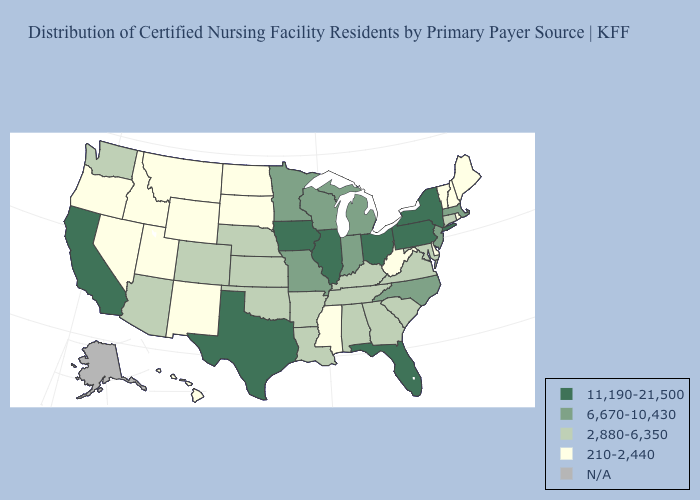Name the states that have a value in the range N/A?
Quick response, please. Alaska. Does the first symbol in the legend represent the smallest category?
Short answer required. No. What is the value of Alaska?
Be succinct. N/A. Among the states that border Oklahoma , does Arkansas have the highest value?
Be succinct. No. Name the states that have a value in the range 6,670-10,430?
Quick response, please. Indiana, Massachusetts, Michigan, Minnesota, Missouri, New Jersey, North Carolina, Wisconsin. Name the states that have a value in the range 6,670-10,430?
Keep it brief. Indiana, Massachusetts, Michigan, Minnesota, Missouri, New Jersey, North Carolina, Wisconsin. Does Florida have the lowest value in the USA?
Short answer required. No. Name the states that have a value in the range 2,880-6,350?
Quick response, please. Alabama, Arizona, Arkansas, Colorado, Connecticut, Georgia, Kansas, Kentucky, Louisiana, Maryland, Nebraska, Oklahoma, South Carolina, Tennessee, Virginia, Washington. What is the value of California?
Write a very short answer. 11,190-21,500. What is the lowest value in states that border Minnesota?
Write a very short answer. 210-2,440. What is the lowest value in the West?
Concise answer only. 210-2,440. Does West Virginia have the lowest value in the USA?
Give a very brief answer. Yes. Does Michigan have the lowest value in the MidWest?
Keep it brief. No. What is the highest value in states that border South Carolina?
Give a very brief answer. 6,670-10,430. 